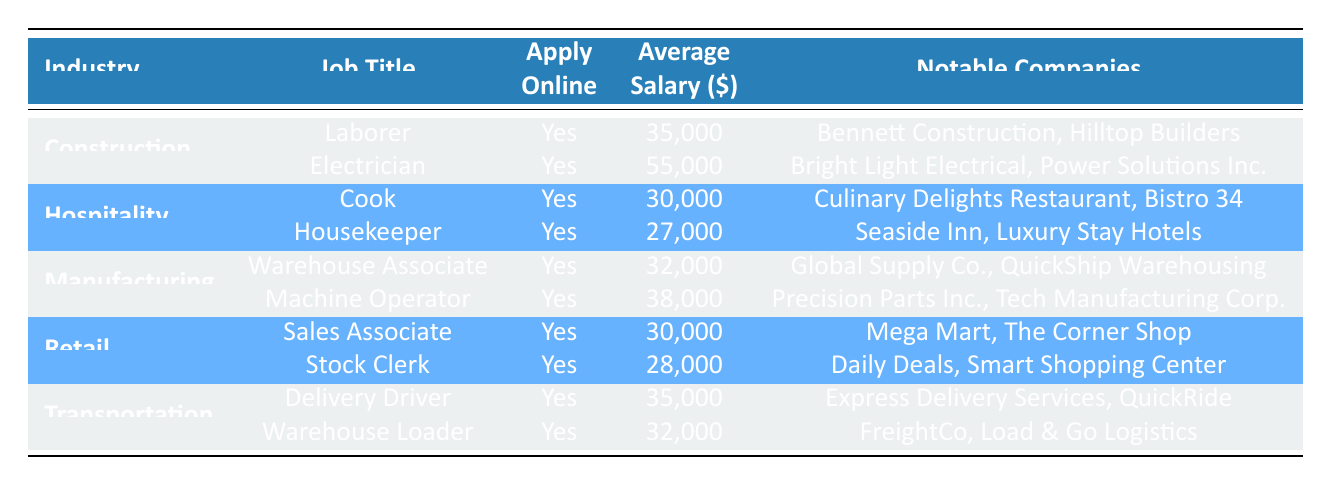What is the job title with the highest average salary in the table? By scanning the average salary column for each job title, the highest figure is 55,000, corresponding to the Electrician position in the Construction industry.
Answer: Electrician How many industries have job opportunities listed in the table? The table lists five distinct industries: Construction, Hospitality, Manufacturing, Retail, and Transportation. Counting these gives us a total of five industries.
Answer: 5 Which industry offers a position with a salary of 30,000? The Hospitality and Retail industries both list job titles with an average salary of 30,000; the Cook in Hospitality and the Sales Associate in Retail.
Answer: Hospitality and Retail What is the average salary of jobs available in the Manufacturing industry? The two available jobs in Manufacturing are Warehouse Associate with a salary of 32,000 and Machine Operator with a salary of 38,000. To find the average, we add these salaries (32,000 + 38,000 = 70,000) and divide by 2, which gives us 35,000.
Answer: 35,000 Is there a job in the Transportation industry that does not require an online application? The table indicates that all listed jobs, both Delivery Driver and Warehouse Loader in the Transportation industry, have the option to apply online, thus the answer is no.
Answer: No Which job title has the lowest average salary, and what is that salary? By comparing all job salaries in the table, the job with the lowest average salary is the Housekeeper in the Hospitality industry at 27,000.
Answer: Housekeeper, 27,000 If I combine the average salaries of both jobs in the Retail industry, what would the total be? The average salaries for the Sales Associate and Stock Clerk in Retail are 30,000 and 28,000, respectively. Adding these figures together gives a total of 58,000.
Answer: 58,000 How many notable companies are associated with the Cook job, and what are they? Two notable companies are listed for the Cook position in Hospitality: Culinary Delights Restaurant and Bistro 34. Therefore, there are two companies associated with this job title.
Answer: 2, Culinary Delights Restaurant, Bistro 34 If I want to work as a Delivery Driver, which company can I apply to? For the Delivery Driver position in Transportation, notable companies include Express Delivery Services and QuickRide. You can apply to either of these companies.
Answer: Express Delivery Services, QuickRide 